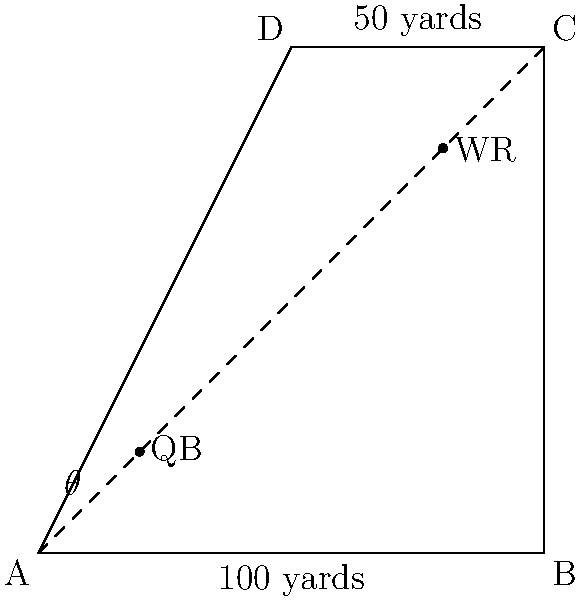During a crucial play, your quarterback (QB) is at point (20,20) on the field diagram, and the wide receiver (WR) is at point (80,80). The angle between the QB's line of sight to the WR and the sideline AB is $\theta$. If the field is 100 yards long and 50 yards wide, what is the value of $\theta$ in degrees? To solve this problem, we'll follow these steps:

1) First, we need to identify the triangle formed by the QB, WR, and the corner of the field (point A).

2) We can calculate the distance between QB and WR using the distance formula:
   $$d = \sqrt{(x_2-x_1)^2 + (y_2-y_1)^2}$$
   $$d = \sqrt{(80-20)^2 + (80-20)^2} = \sqrt{3600 + 3600} = \sqrt{7200} = 60\sqrt{2}$$ yards

3) Now, we have a right triangle with the following sides:
   - Base (QB to sideline): 20 yards
   - Height (WR to sideline): 80 yards
   - Hypotenuse: $60\sqrt{2}$ yards

4) We can use the tangent function to find $\theta$:
   $$\tan(\theta) = \frac{\text{opposite}}{\text{adjacent}} = \frac{80}{20} = 4$$

5) To get $\theta$, we need to use the inverse tangent (arctangent) function:
   $$\theta = \arctan(4)$$

6) Using a calculator or trigonometric tables, we find:
   $$\theta \approx 75.96 \text{ degrees}$$

Therefore, the angle $\theta$ is approximately 75.96 degrees.
Answer: 75.96 degrees 